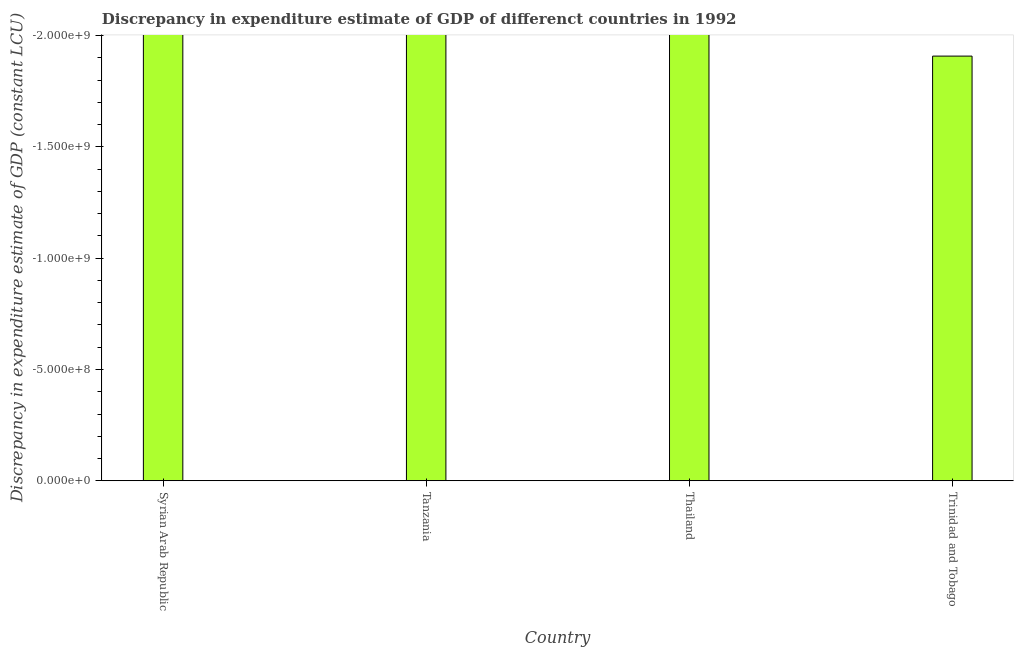What is the title of the graph?
Offer a terse response. Discrepancy in expenditure estimate of GDP of differenct countries in 1992. What is the label or title of the Y-axis?
Make the answer very short. Discrepancy in expenditure estimate of GDP (constant LCU). What is the discrepancy in expenditure estimate of gdp in Thailand?
Provide a succinct answer. 0. What is the average discrepancy in expenditure estimate of gdp per country?
Provide a short and direct response. 0. How many bars are there?
Make the answer very short. 0. Are all the bars in the graph horizontal?
Your response must be concise. No. How many countries are there in the graph?
Make the answer very short. 4. What is the difference between two consecutive major ticks on the Y-axis?
Your answer should be very brief. 5.00e+08. What is the Discrepancy in expenditure estimate of GDP (constant LCU) of Tanzania?
Ensure brevity in your answer.  0. 